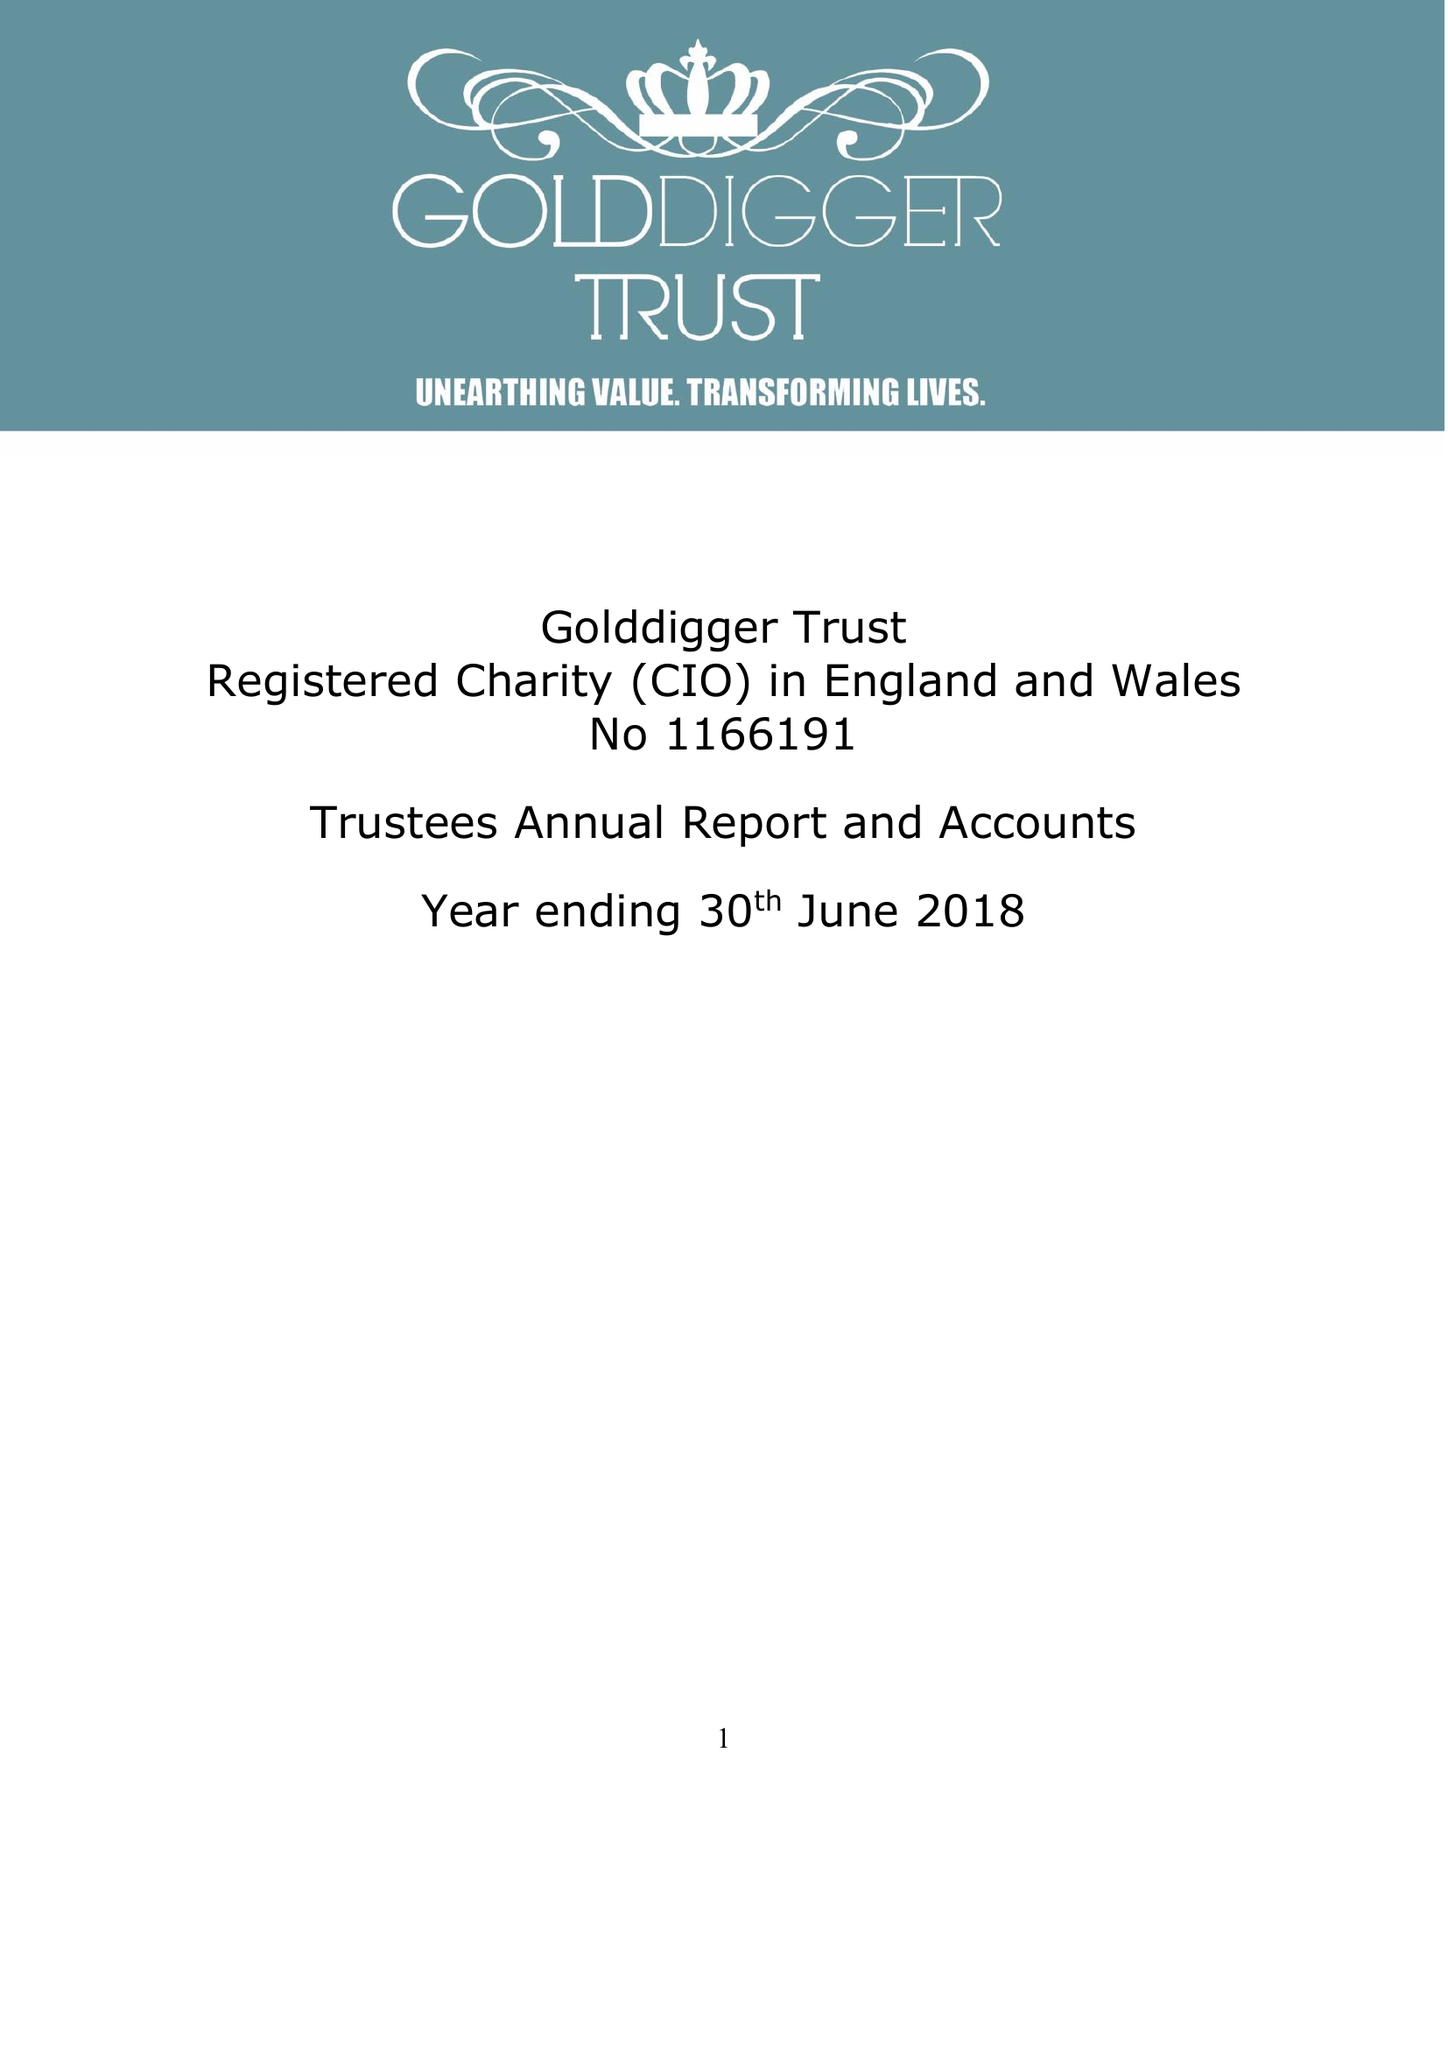What is the value for the address__street_line?
Answer the question using a single word or phrase. 10 PSALTER LANE 